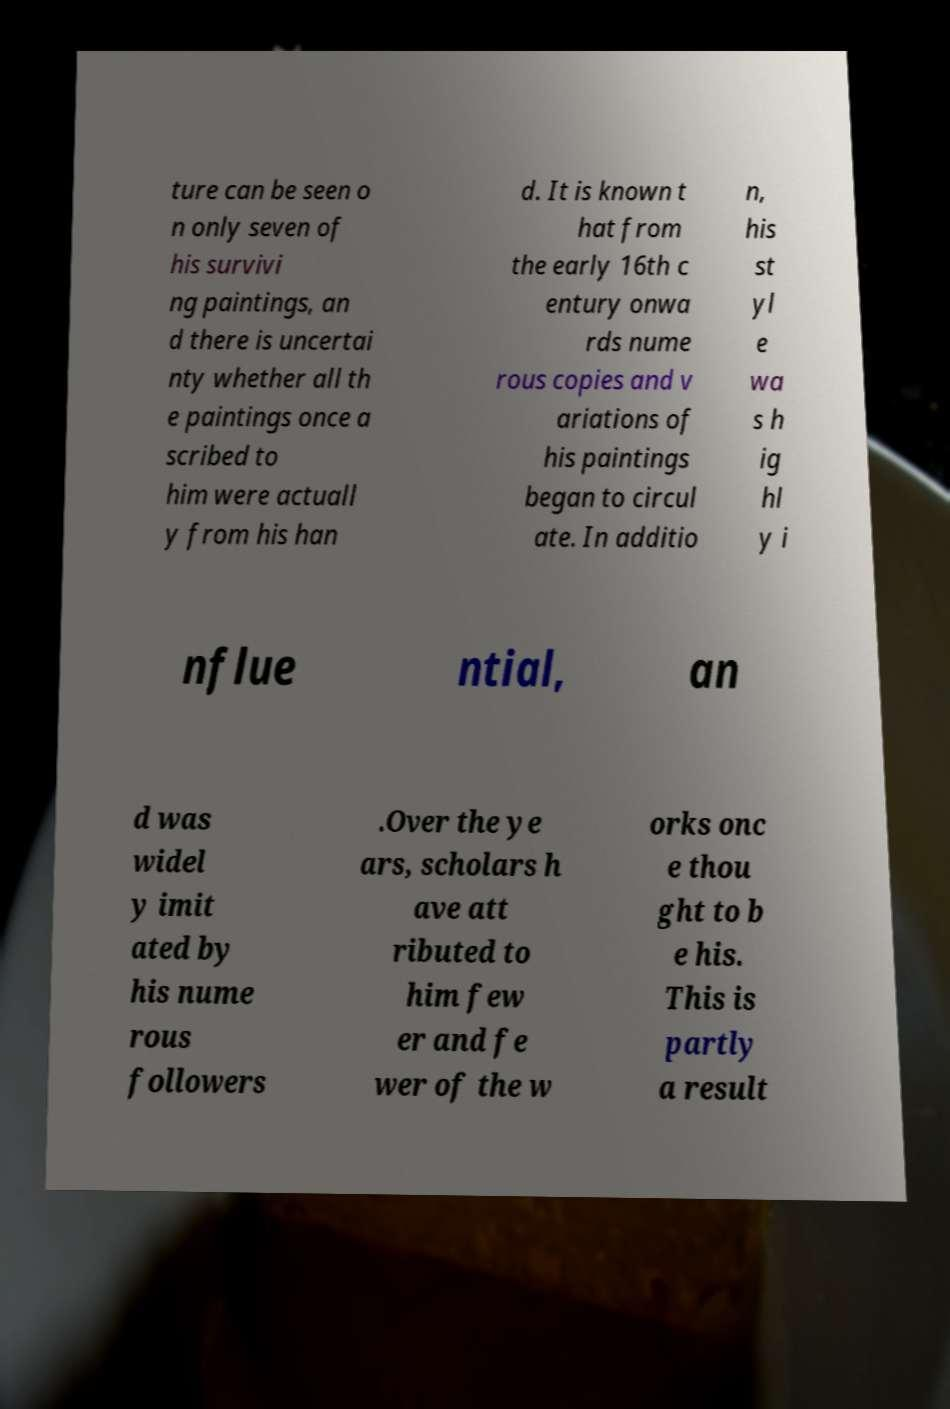For documentation purposes, I need the text within this image transcribed. Could you provide that? ture can be seen o n only seven of his survivi ng paintings, an d there is uncertai nty whether all th e paintings once a scribed to him were actuall y from his han d. It is known t hat from the early 16th c entury onwa rds nume rous copies and v ariations of his paintings began to circul ate. In additio n, his st yl e wa s h ig hl y i nflue ntial, an d was widel y imit ated by his nume rous followers .Over the ye ars, scholars h ave att ributed to him few er and fe wer of the w orks onc e thou ght to b e his. This is partly a result 